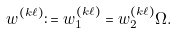Convert formula to latex. <formula><loc_0><loc_0><loc_500><loc_500>w ^ { ( k \ell ) } \colon = w _ { 1 } ^ { ( k \ell ) } = w _ { 2 } ^ { ( k \ell ) } \Omega .</formula> 